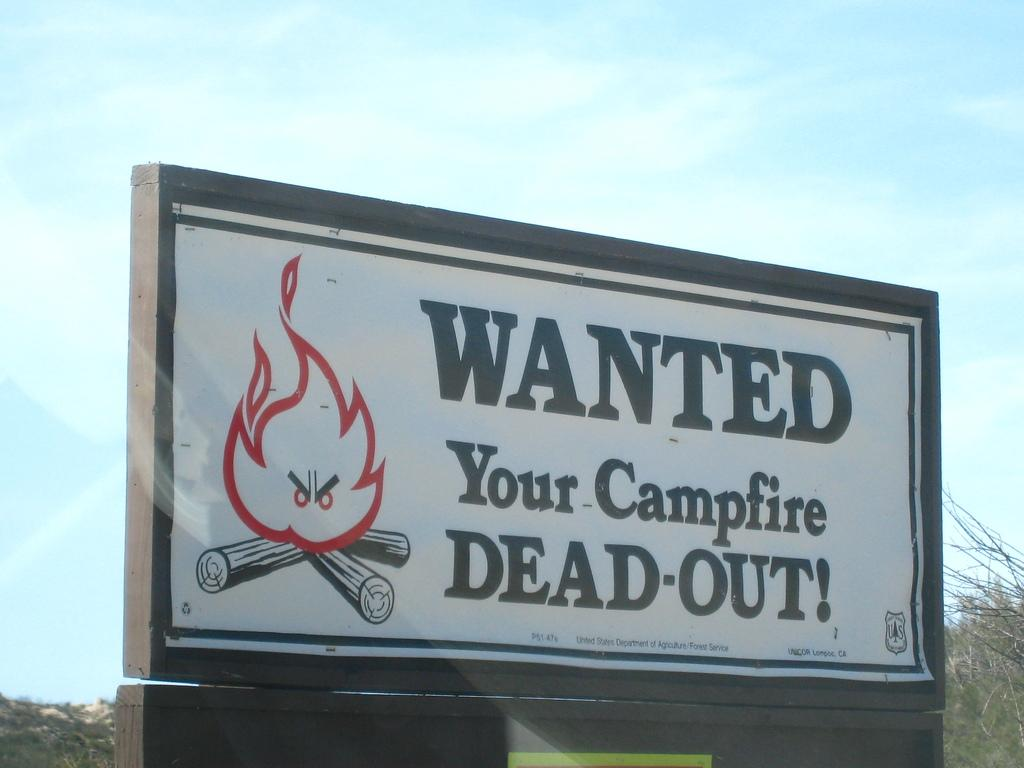What is located in the foreground of the image? There is a board with text in the foreground of the image. What does the text on the board say? The text on the board says "Wanted your camp fire dead out!". What can be seen in the background of the image? There are trees and the sky visible in the background of the image. What color is the chalk used to write the text on the board? There is no mention of chalk being used to write the text on the board, and the color of the text is not specified in the image. 